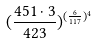Convert formula to latex. <formula><loc_0><loc_0><loc_500><loc_500>( \frac { 4 5 1 \cdot 3 } { 4 2 3 } ) ^ { ( \frac { 6 } { 1 1 7 } ) ^ { 4 } }</formula> 